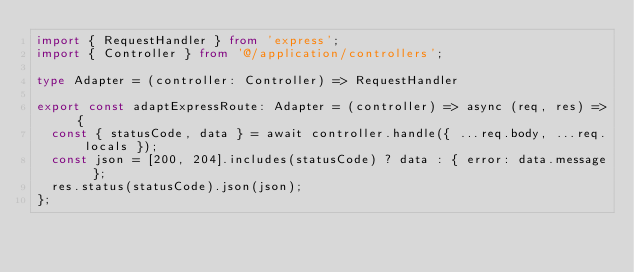Convert code to text. <code><loc_0><loc_0><loc_500><loc_500><_TypeScript_>import { RequestHandler } from 'express';
import { Controller } from '@/application/controllers';

type Adapter = (controller: Controller) => RequestHandler

export const adaptExpressRoute: Adapter = (controller) => async (req, res) => {
  const { statusCode, data } = await controller.handle({ ...req.body, ...req.locals });
  const json = [200, 204].includes(statusCode) ? data : { error: data.message };
  res.status(statusCode).json(json);
};
</code> 